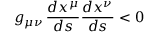Convert formula to latex. <formula><loc_0><loc_0><loc_500><loc_500>g _ { \mu \nu } \, { \frac { d x ^ { \mu } } { d s } } { \frac { d x ^ { \nu } } { d s } } < 0</formula> 